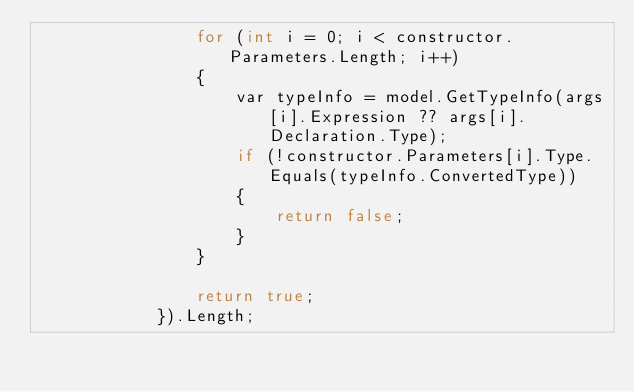<code> <loc_0><loc_0><loc_500><loc_500><_C#_>                for (int i = 0; i < constructor.Parameters.Length; i++)
                {
                    var typeInfo = model.GetTypeInfo(args[i].Expression ?? args[i].Declaration.Type);
                    if (!constructor.Parameters[i].Type.Equals(typeInfo.ConvertedType))
                    {
                        return false;
                    }
                }

                return true;
            }).Length;
</code> 